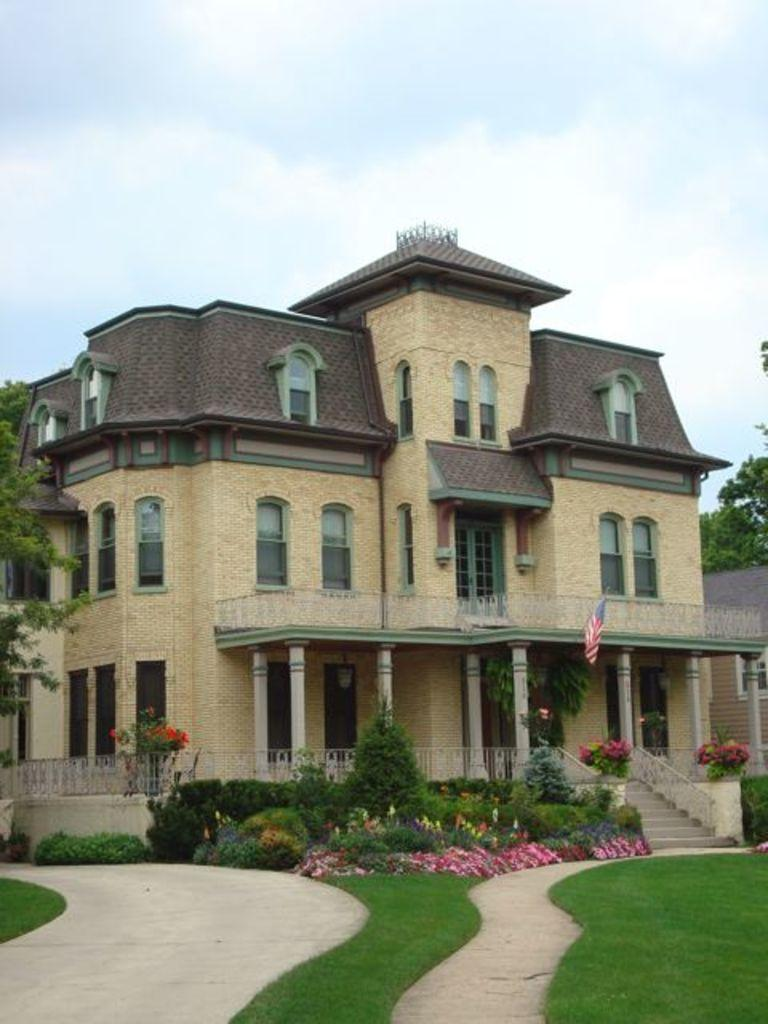What is the main subject in the middle of the image? There is a building in the middle of the image. What can be seen on the left side of the image? There are trees on the left side of the image. What is the condition of the sky in the image? The sky is cloudy in the image. What type of card is being used to support the building in the image? There is no card present in the image, and the building is not being supported by any visible means. 